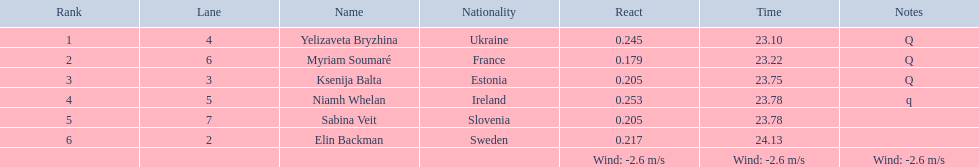How many last names begin with the letter "b"? 3. 